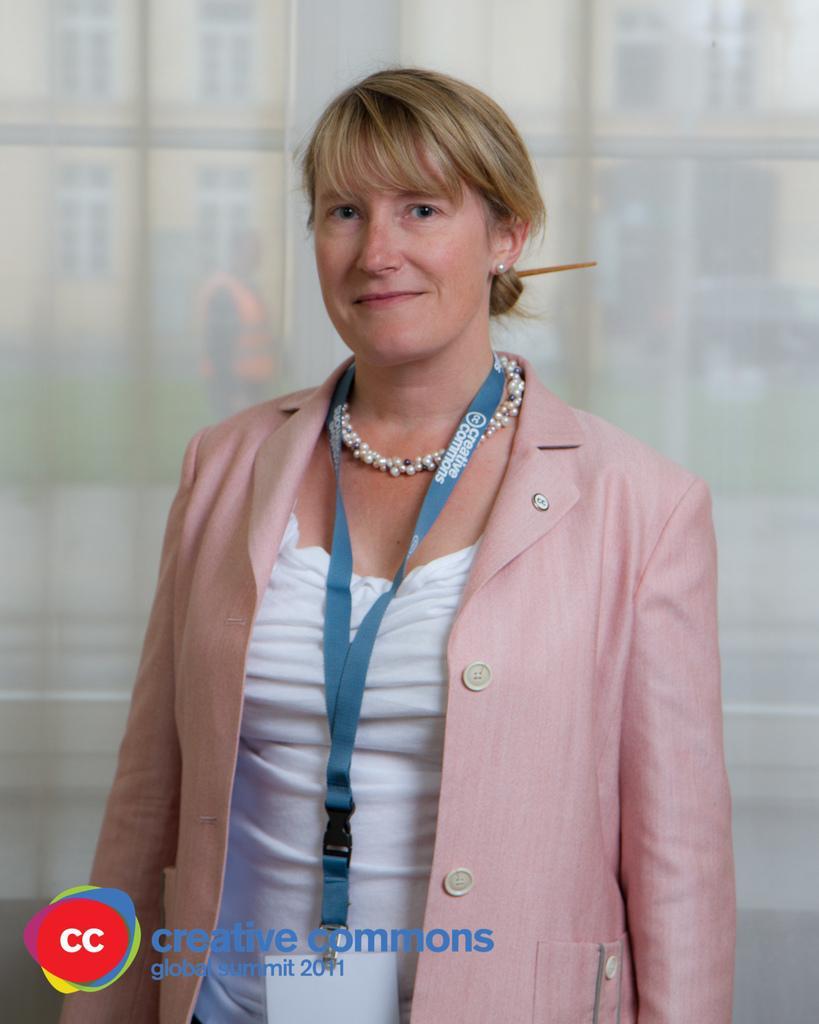Can you describe this image briefly? In this image we can see a woman standing in-front of glass wall, also there is a water mark at the bottom. 